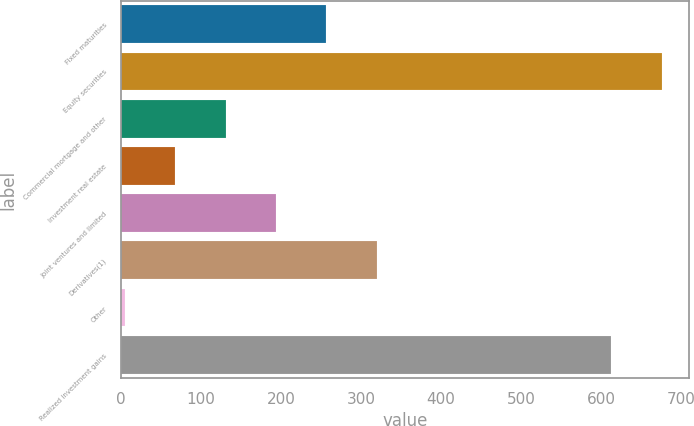Convert chart to OTSL. <chart><loc_0><loc_0><loc_500><loc_500><bar_chart><fcel>Fixed maturities<fcel>Equity securities<fcel>Commercial mortgage and other<fcel>Investment real estate<fcel>Joint ventures and limited<fcel>Derivatives(1)<fcel>Other<fcel>Realized investment gains<nl><fcel>256.6<fcel>675.9<fcel>130.8<fcel>67.9<fcel>193.7<fcel>319.5<fcel>5<fcel>613<nl></chart> 